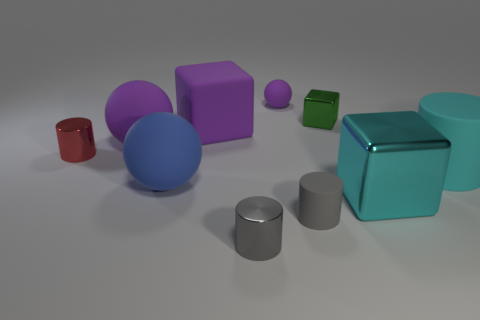How many other objects are there of the same color as the big cylinder?
Keep it short and to the point. 1. Is the number of cyan cylinders in front of the small gray rubber object less than the number of large purple spheres?
Your answer should be compact. Yes. How many rubber cylinders are there?
Your answer should be compact. 2. How many tiny red cylinders have the same material as the large cyan cube?
Give a very brief answer. 1. How many objects are either gray cylinders that are to the right of the tiny gray metal cylinder or large objects?
Provide a succinct answer. 6. Are there fewer big objects that are behind the small purple sphere than matte objects in front of the large purple matte ball?
Your answer should be very brief. Yes. Are there any large blue matte things in front of the gray metal object?
Ensure brevity in your answer.  No. How many objects are either metal cylinders behind the big rubber cylinder or matte objects to the right of the small green metallic object?
Provide a short and direct response. 2. How many large cubes are the same color as the big cylinder?
Offer a terse response. 1. What is the color of the other large thing that is the same shape as the cyan metallic thing?
Your answer should be compact. Purple. 